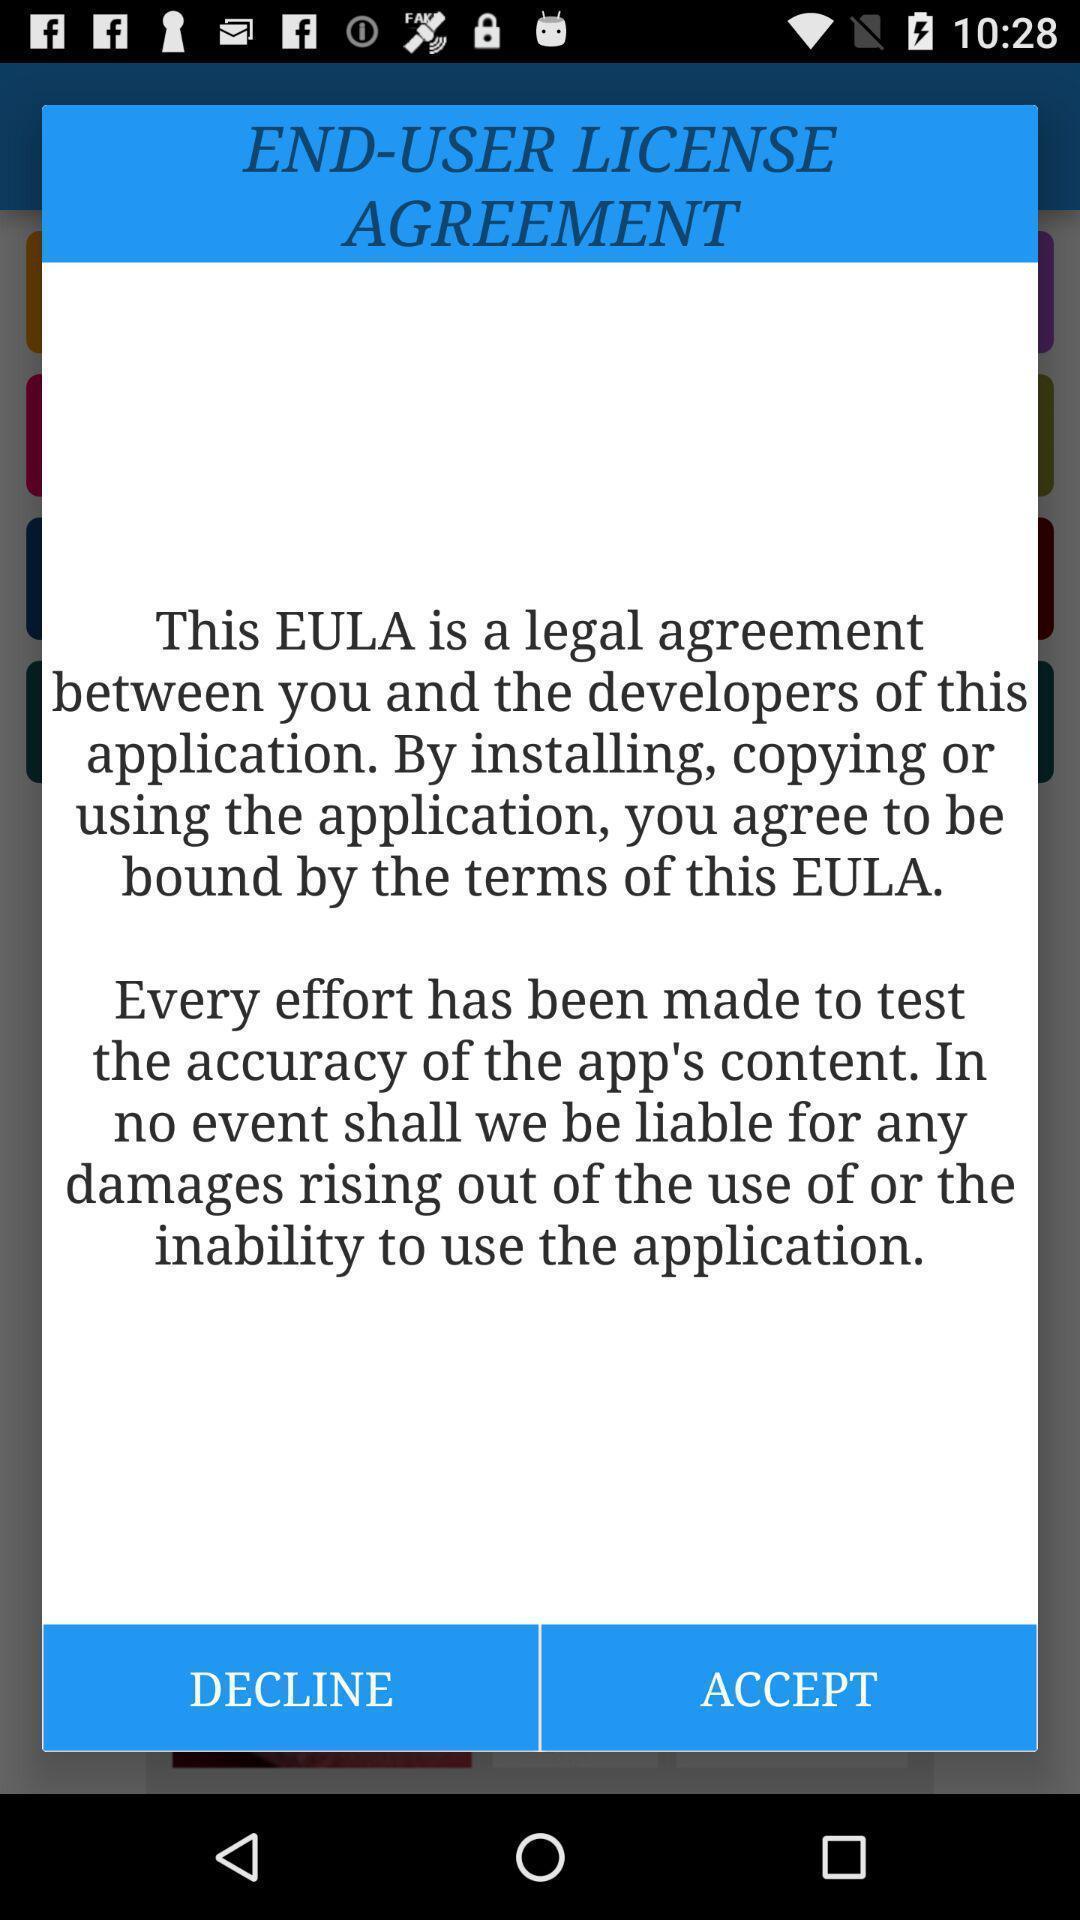Give me a summary of this screen capture. Pop up showing to accept license agreement. 